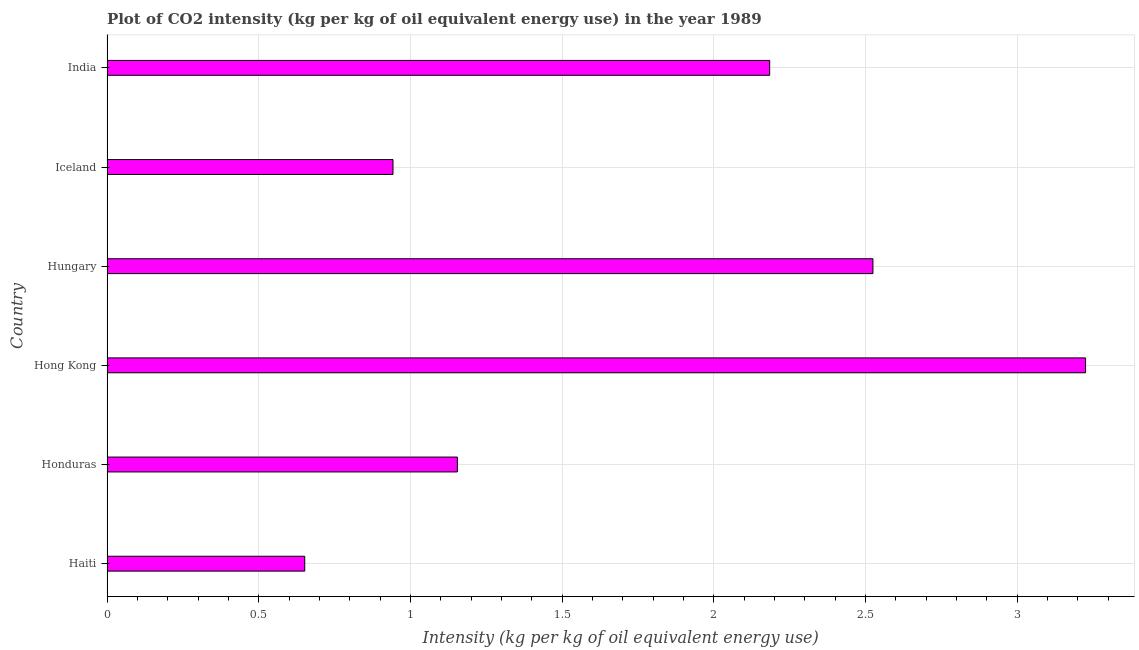Does the graph contain any zero values?
Ensure brevity in your answer.  No. What is the title of the graph?
Your answer should be very brief. Plot of CO2 intensity (kg per kg of oil equivalent energy use) in the year 1989. What is the label or title of the X-axis?
Your answer should be very brief. Intensity (kg per kg of oil equivalent energy use). What is the co2 intensity in Hungary?
Make the answer very short. 2.53. Across all countries, what is the maximum co2 intensity?
Make the answer very short. 3.23. Across all countries, what is the minimum co2 intensity?
Your answer should be compact. 0.65. In which country was the co2 intensity maximum?
Offer a terse response. Hong Kong. In which country was the co2 intensity minimum?
Your response must be concise. Haiti. What is the sum of the co2 intensity?
Ensure brevity in your answer.  10.69. What is the difference between the co2 intensity in Hong Kong and Hungary?
Offer a very short reply. 0.7. What is the average co2 intensity per country?
Offer a very short reply. 1.78. What is the median co2 intensity?
Make the answer very short. 1.67. In how many countries, is the co2 intensity greater than 1.7 kg?
Your answer should be very brief. 3. What is the ratio of the co2 intensity in Haiti to that in Hong Kong?
Give a very brief answer. 0.2. Is the co2 intensity in Haiti less than that in Iceland?
Offer a terse response. Yes. Is the difference between the co2 intensity in Honduras and Hong Kong greater than the difference between any two countries?
Make the answer very short. No. What is the difference between the highest and the second highest co2 intensity?
Provide a short and direct response. 0.7. Is the sum of the co2 intensity in Haiti and India greater than the maximum co2 intensity across all countries?
Provide a succinct answer. No. What is the difference between the highest and the lowest co2 intensity?
Give a very brief answer. 2.57. In how many countries, is the co2 intensity greater than the average co2 intensity taken over all countries?
Provide a succinct answer. 3. How many bars are there?
Provide a short and direct response. 6. What is the Intensity (kg per kg of oil equivalent energy use) of Haiti?
Offer a terse response. 0.65. What is the Intensity (kg per kg of oil equivalent energy use) of Honduras?
Offer a terse response. 1.16. What is the Intensity (kg per kg of oil equivalent energy use) in Hong Kong?
Provide a succinct answer. 3.23. What is the Intensity (kg per kg of oil equivalent energy use) of Hungary?
Ensure brevity in your answer.  2.53. What is the Intensity (kg per kg of oil equivalent energy use) in Iceland?
Ensure brevity in your answer.  0.94. What is the Intensity (kg per kg of oil equivalent energy use) of India?
Ensure brevity in your answer.  2.18. What is the difference between the Intensity (kg per kg of oil equivalent energy use) in Haiti and Honduras?
Keep it short and to the point. -0.5. What is the difference between the Intensity (kg per kg of oil equivalent energy use) in Haiti and Hong Kong?
Make the answer very short. -2.57. What is the difference between the Intensity (kg per kg of oil equivalent energy use) in Haiti and Hungary?
Offer a very short reply. -1.87. What is the difference between the Intensity (kg per kg of oil equivalent energy use) in Haiti and Iceland?
Your response must be concise. -0.29. What is the difference between the Intensity (kg per kg of oil equivalent energy use) in Haiti and India?
Keep it short and to the point. -1.53. What is the difference between the Intensity (kg per kg of oil equivalent energy use) in Honduras and Hong Kong?
Ensure brevity in your answer.  -2.07. What is the difference between the Intensity (kg per kg of oil equivalent energy use) in Honduras and Hungary?
Provide a succinct answer. -1.37. What is the difference between the Intensity (kg per kg of oil equivalent energy use) in Honduras and Iceland?
Make the answer very short. 0.21. What is the difference between the Intensity (kg per kg of oil equivalent energy use) in Honduras and India?
Ensure brevity in your answer.  -1.03. What is the difference between the Intensity (kg per kg of oil equivalent energy use) in Hong Kong and Hungary?
Offer a terse response. 0.7. What is the difference between the Intensity (kg per kg of oil equivalent energy use) in Hong Kong and Iceland?
Ensure brevity in your answer.  2.28. What is the difference between the Intensity (kg per kg of oil equivalent energy use) in Hong Kong and India?
Your answer should be compact. 1.04. What is the difference between the Intensity (kg per kg of oil equivalent energy use) in Hungary and Iceland?
Your answer should be compact. 1.58. What is the difference between the Intensity (kg per kg of oil equivalent energy use) in Hungary and India?
Your response must be concise. 0.34. What is the difference between the Intensity (kg per kg of oil equivalent energy use) in Iceland and India?
Ensure brevity in your answer.  -1.24. What is the ratio of the Intensity (kg per kg of oil equivalent energy use) in Haiti to that in Honduras?
Offer a terse response. 0.56. What is the ratio of the Intensity (kg per kg of oil equivalent energy use) in Haiti to that in Hong Kong?
Keep it short and to the point. 0.2. What is the ratio of the Intensity (kg per kg of oil equivalent energy use) in Haiti to that in Hungary?
Offer a very short reply. 0.26. What is the ratio of the Intensity (kg per kg of oil equivalent energy use) in Haiti to that in Iceland?
Offer a very short reply. 0.69. What is the ratio of the Intensity (kg per kg of oil equivalent energy use) in Haiti to that in India?
Your answer should be compact. 0.3. What is the ratio of the Intensity (kg per kg of oil equivalent energy use) in Honduras to that in Hong Kong?
Offer a very short reply. 0.36. What is the ratio of the Intensity (kg per kg of oil equivalent energy use) in Honduras to that in Hungary?
Provide a short and direct response. 0.46. What is the ratio of the Intensity (kg per kg of oil equivalent energy use) in Honduras to that in Iceland?
Make the answer very short. 1.23. What is the ratio of the Intensity (kg per kg of oil equivalent energy use) in Honduras to that in India?
Give a very brief answer. 0.53. What is the ratio of the Intensity (kg per kg of oil equivalent energy use) in Hong Kong to that in Hungary?
Your response must be concise. 1.28. What is the ratio of the Intensity (kg per kg of oil equivalent energy use) in Hong Kong to that in Iceland?
Offer a terse response. 3.42. What is the ratio of the Intensity (kg per kg of oil equivalent energy use) in Hong Kong to that in India?
Ensure brevity in your answer.  1.48. What is the ratio of the Intensity (kg per kg of oil equivalent energy use) in Hungary to that in Iceland?
Keep it short and to the point. 2.68. What is the ratio of the Intensity (kg per kg of oil equivalent energy use) in Hungary to that in India?
Your answer should be very brief. 1.16. What is the ratio of the Intensity (kg per kg of oil equivalent energy use) in Iceland to that in India?
Provide a short and direct response. 0.43. 